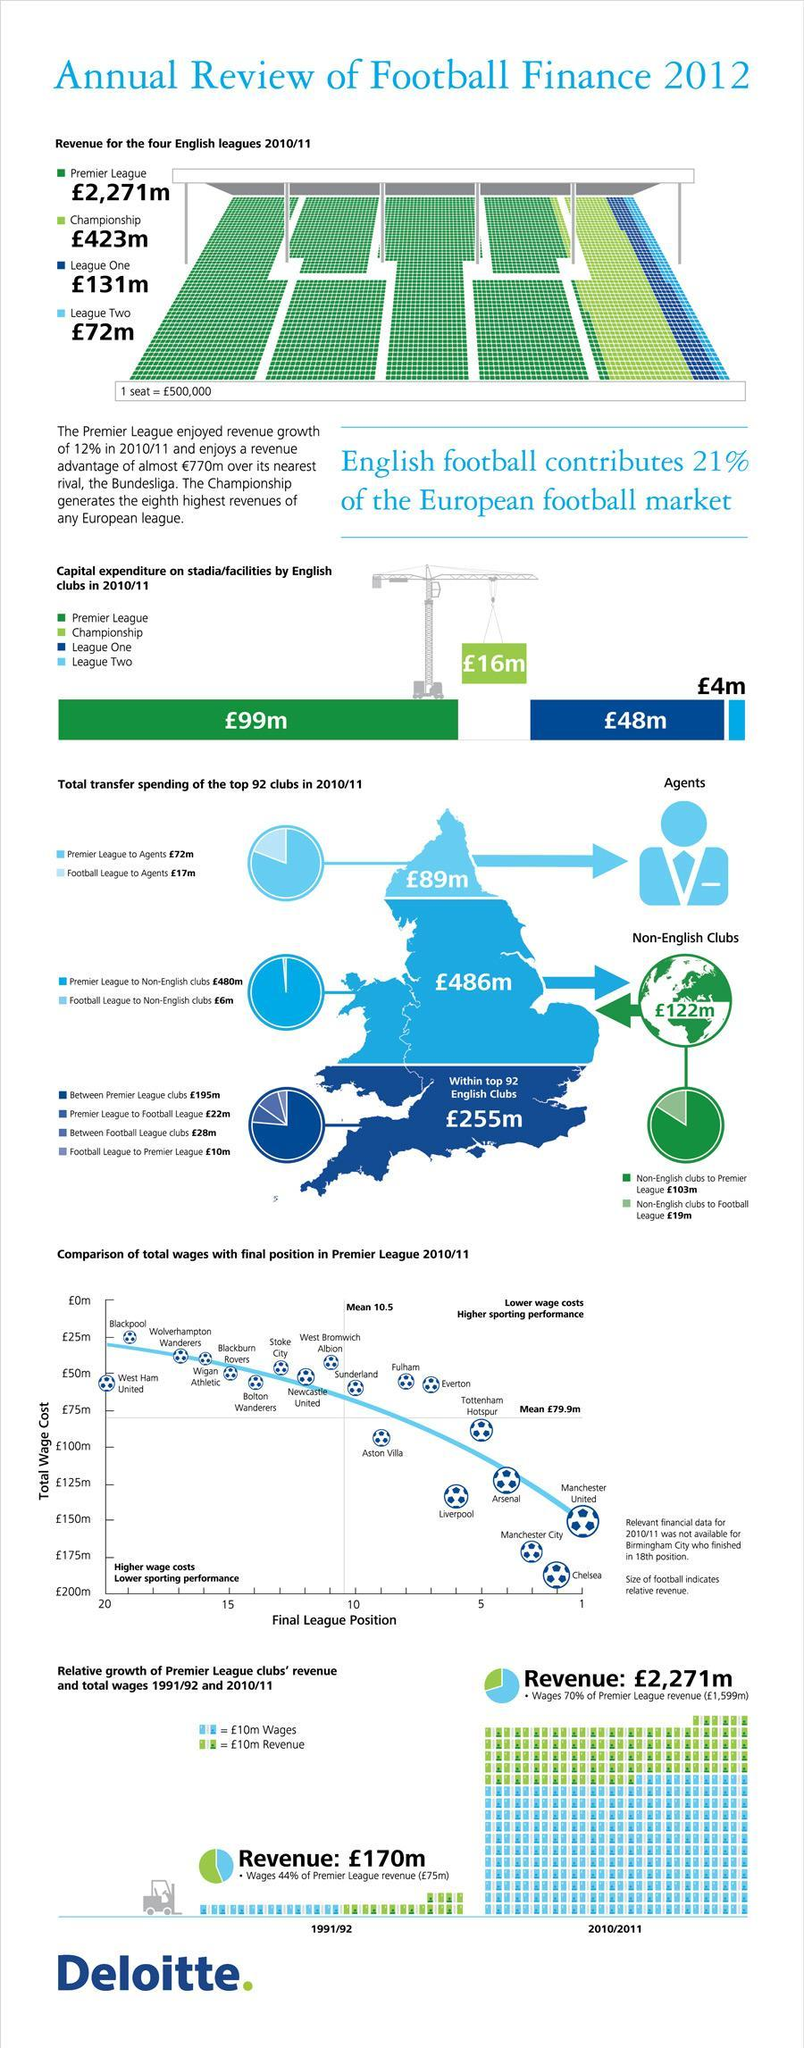Which team spent the second highest capital on facilities?
Answer the question with a short phrase. League One What is the difference in transfer spending to non-English clubs in pounds between Premier and Football leagues? 474 m What is the difference in transfer spending to agents in pounds between Premier and Football leagues? 55 m What is number in pounds that is written on the pulley of the crane? 16 m Which team is in the second highest league position with the highest total wage cost ? Chelsea What is amount paid in pounds to Premier League by the non- English clubs, 103m, 480m, or 122m? 103m What was the capital expenditure in pounds on stadia for Championship league,  99m, 48m, 4m, or 16m? 16m What was the total revenue in pounds for all four English leagues in 2010/11? 2,897 Which team has the highest league position with a third highest total wage cost? Manchester United What is the amount written in pounds on the globe? 122 m 